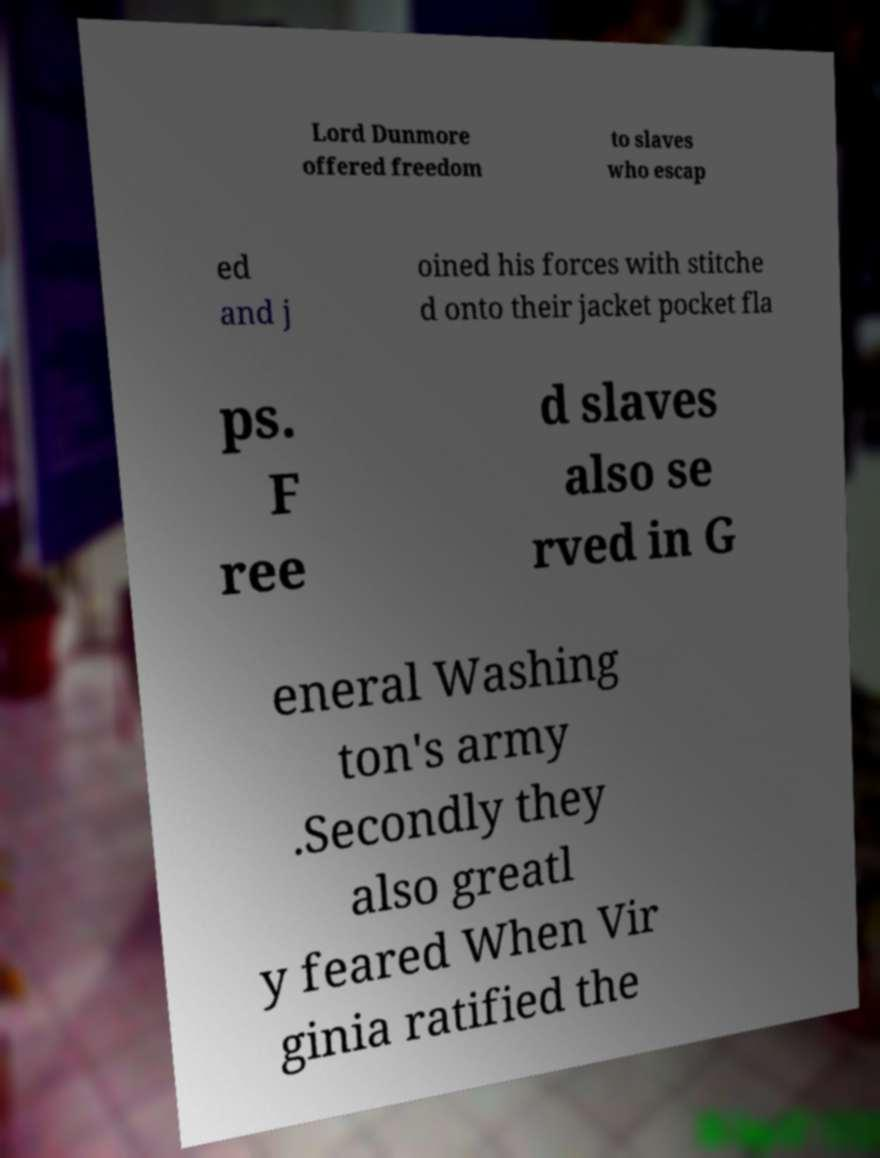What messages or text are displayed in this image? I need them in a readable, typed format. Lord Dunmore offered freedom to slaves who escap ed and j oined his forces with stitche d onto their jacket pocket fla ps. F ree d slaves also se rved in G eneral Washing ton's army .Secondly they also greatl y feared When Vir ginia ratified the 